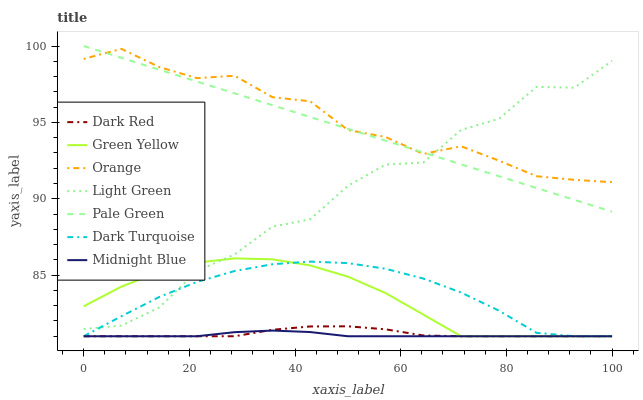Does Midnight Blue have the minimum area under the curve?
Answer yes or no. Yes. Does Orange have the maximum area under the curve?
Answer yes or no. Yes. Does Dark Red have the minimum area under the curve?
Answer yes or no. No. Does Dark Red have the maximum area under the curve?
Answer yes or no. No. Is Pale Green the smoothest?
Answer yes or no. Yes. Is Light Green the roughest?
Answer yes or no. Yes. Is Dark Red the smoothest?
Answer yes or no. No. Is Dark Red the roughest?
Answer yes or no. No. Does Midnight Blue have the lowest value?
Answer yes or no. Yes. Does Pale Green have the lowest value?
Answer yes or no. No. Does Pale Green have the highest value?
Answer yes or no. Yes. Does Dark Red have the highest value?
Answer yes or no. No. Is Midnight Blue less than Pale Green?
Answer yes or no. Yes. Is Orange greater than Midnight Blue?
Answer yes or no. Yes. Does Midnight Blue intersect Dark Turquoise?
Answer yes or no. Yes. Is Midnight Blue less than Dark Turquoise?
Answer yes or no. No. Is Midnight Blue greater than Dark Turquoise?
Answer yes or no. No. Does Midnight Blue intersect Pale Green?
Answer yes or no. No. 